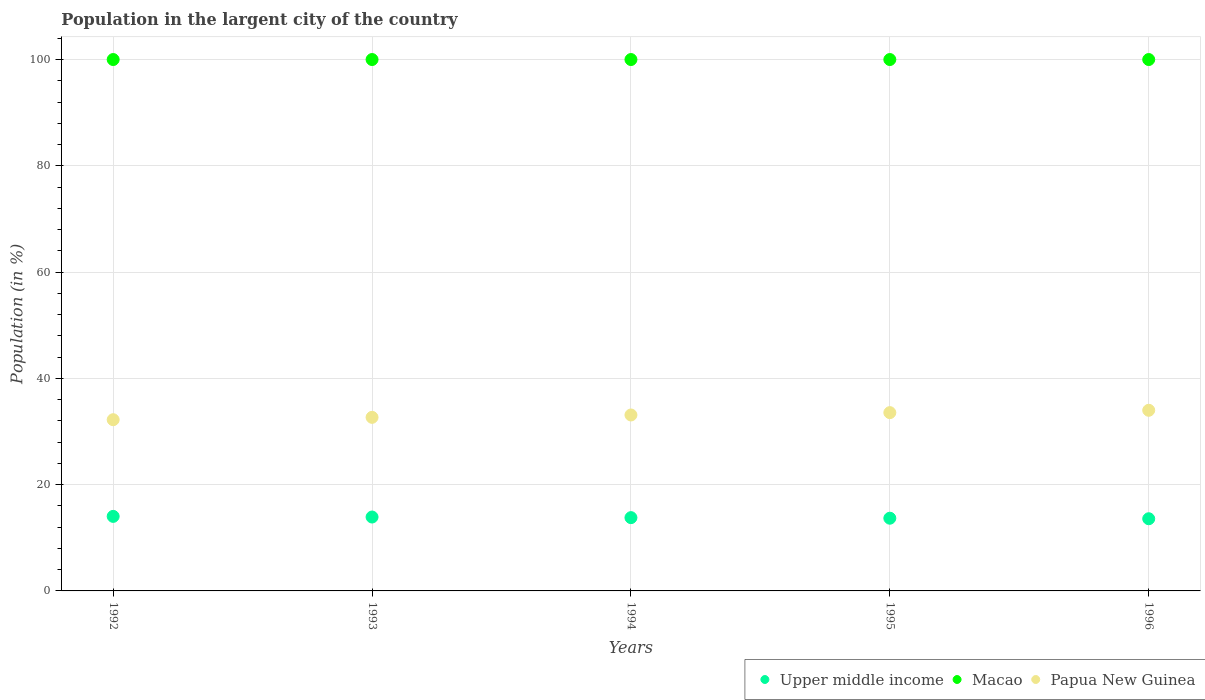How many different coloured dotlines are there?
Offer a terse response. 3. What is the percentage of population in the largent city in Upper middle income in 1993?
Give a very brief answer. 13.91. Across all years, what is the maximum percentage of population in the largent city in Papua New Guinea?
Provide a short and direct response. 33.99. Across all years, what is the minimum percentage of population in the largent city in Papua New Guinea?
Offer a terse response. 32.22. What is the total percentage of population in the largent city in Macao in the graph?
Your answer should be very brief. 500. What is the difference between the percentage of population in the largent city in Papua New Guinea in 1994 and that in 1995?
Your answer should be compact. -0.44. What is the difference between the percentage of population in the largent city in Upper middle income in 1993 and the percentage of population in the largent city in Papua New Guinea in 1996?
Your answer should be compact. -20.09. What is the average percentage of population in the largent city in Upper middle income per year?
Ensure brevity in your answer.  13.8. In the year 1994, what is the difference between the percentage of population in the largent city in Papua New Guinea and percentage of population in the largent city in Upper middle income?
Offer a very short reply. 19.32. In how many years, is the percentage of population in the largent city in Macao greater than 64 %?
Offer a terse response. 5. What is the ratio of the percentage of population in the largent city in Upper middle income in 1993 to that in 1996?
Offer a very short reply. 1.02. What is the difference between the highest and the second highest percentage of population in the largent city in Upper middle income?
Ensure brevity in your answer.  0.12. What is the difference between the highest and the lowest percentage of population in the largent city in Papua New Guinea?
Your answer should be very brief. 1.77. Is it the case that in every year, the sum of the percentage of population in the largent city in Upper middle income and percentage of population in the largent city in Macao  is greater than the percentage of population in the largent city in Papua New Guinea?
Your answer should be compact. Yes. Does the percentage of population in the largent city in Papua New Guinea monotonically increase over the years?
Make the answer very short. Yes. Is the percentage of population in the largent city in Macao strictly greater than the percentage of population in the largent city in Upper middle income over the years?
Keep it short and to the point. Yes. How many dotlines are there?
Provide a short and direct response. 3. How many years are there in the graph?
Your answer should be very brief. 5. Are the values on the major ticks of Y-axis written in scientific E-notation?
Offer a very short reply. No. How many legend labels are there?
Provide a short and direct response. 3. What is the title of the graph?
Your response must be concise. Population in the largent city of the country. Does "Bermuda" appear as one of the legend labels in the graph?
Give a very brief answer. No. What is the label or title of the Y-axis?
Provide a short and direct response. Population (in %). What is the Population (in %) in Upper middle income in 1992?
Your answer should be very brief. 14.03. What is the Population (in %) in Macao in 1992?
Make the answer very short. 100. What is the Population (in %) of Papua New Guinea in 1992?
Provide a succinct answer. 32.22. What is the Population (in %) of Upper middle income in 1993?
Provide a succinct answer. 13.91. What is the Population (in %) in Papua New Guinea in 1993?
Give a very brief answer. 32.66. What is the Population (in %) of Upper middle income in 1994?
Keep it short and to the point. 13.79. What is the Population (in %) of Macao in 1994?
Your response must be concise. 100. What is the Population (in %) of Papua New Guinea in 1994?
Give a very brief answer. 33.11. What is the Population (in %) in Upper middle income in 1995?
Offer a very short reply. 13.68. What is the Population (in %) of Papua New Guinea in 1995?
Provide a short and direct response. 33.55. What is the Population (in %) in Upper middle income in 1996?
Your response must be concise. 13.58. What is the Population (in %) of Macao in 1996?
Give a very brief answer. 100. What is the Population (in %) of Papua New Guinea in 1996?
Your answer should be compact. 33.99. Across all years, what is the maximum Population (in %) in Upper middle income?
Make the answer very short. 14.03. Across all years, what is the maximum Population (in %) in Papua New Guinea?
Make the answer very short. 33.99. Across all years, what is the minimum Population (in %) in Upper middle income?
Provide a short and direct response. 13.58. Across all years, what is the minimum Population (in %) in Macao?
Make the answer very short. 100. Across all years, what is the minimum Population (in %) of Papua New Guinea?
Your answer should be compact. 32.22. What is the total Population (in %) of Upper middle income in the graph?
Provide a succinct answer. 68.99. What is the total Population (in %) in Macao in the graph?
Give a very brief answer. 500. What is the total Population (in %) of Papua New Guinea in the graph?
Give a very brief answer. 165.54. What is the difference between the Population (in %) of Upper middle income in 1992 and that in 1993?
Your answer should be compact. 0.12. What is the difference between the Population (in %) of Papua New Guinea in 1992 and that in 1993?
Offer a terse response. -0.44. What is the difference between the Population (in %) of Upper middle income in 1992 and that in 1994?
Offer a very short reply. 0.24. What is the difference between the Population (in %) of Papua New Guinea in 1992 and that in 1994?
Give a very brief answer. -0.89. What is the difference between the Population (in %) in Upper middle income in 1992 and that in 1995?
Offer a terse response. 0.34. What is the difference between the Population (in %) in Papua New Guinea in 1992 and that in 1995?
Give a very brief answer. -1.33. What is the difference between the Population (in %) of Upper middle income in 1992 and that in 1996?
Offer a very short reply. 0.45. What is the difference between the Population (in %) in Macao in 1992 and that in 1996?
Give a very brief answer. 0. What is the difference between the Population (in %) in Papua New Guinea in 1992 and that in 1996?
Give a very brief answer. -1.77. What is the difference between the Population (in %) in Upper middle income in 1993 and that in 1994?
Offer a very short reply. 0.12. What is the difference between the Population (in %) in Papua New Guinea in 1993 and that in 1994?
Give a very brief answer. -0.44. What is the difference between the Population (in %) of Upper middle income in 1993 and that in 1995?
Your response must be concise. 0.22. What is the difference between the Population (in %) of Macao in 1993 and that in 1995?
Keep it short and to the point. 0. What is the difference between the Population (in %) of Papua New Guinea in 1993 and that in 1995?
Offer a terse response. -0.89. What is the difference between the Population (in %) in Upper middle income in 1993 and that in 1996?
Provide a short and direct response. 0.32. What is the difference between the Population (in %) of Papua New Guinea in 1993 and that in 1996?
Provide a short and direct response. -1.33. What is the difference between the Population (in %) of Upper middle income in 1994 and that in 1995?
Ensure brevity in your answer.  0.11. What is the difference between the Population (in %) in Macao in 1994 and that in 1995?
Your response must be concise. -0. What is the difference between the Population (in %) in Papua New Guinea in 1994 and that in 1995?
Ensure brevity in your answer.  -0.44. What is the difference between the Population (in %) of Upper middle income in 1994 and that in 1996?
Ensure brevity in your answer.  0.21. What is the difference between the Population (in %) in Papua New Guinea in 1994 and that in 1996?
Your response must be concise. -0.88. What is the difference between the Population (in %) in Upper middle income in 1995 and that in 1996?
Offer a terse response. 0.1. What is the difference between the Population (in %) of Macao in 1995 and that in 1996?
Provide a succinct answer. 0. What is the difference between the Population (in %) of Papua New Guinea in 1995 and that in 1996?
Make the answer very short. -0.44. What is the difference between the Population (in %) in Upper middle income in 1992 and the Population (in %) in Macao in 1993?
Provide a succinct answer. -85.97. What is the difference between the Population (in %) of Upper middle income in 1992 and the Population (in %) of Papua New Guinea in 1993?
Keep it short and to the point. -18.64. What is the difference between the Population (in %) in Macao in 1992 and the Population (in %) in Papua New Guinea in 1993?
Offer a very short reply. 67.34. What is the difference between the Population (in %) of Upper middle income in 1992 and the Population (in %) of Macao in 1994?
Provide a succinct answer. -85.97. What is the difference between the Population (in %) in Upper middle income in 1992 and the Population (in %) in Papua New Guinea in 1994?
Ensure brevity in your answer.  -19.08. What is the difference between the Population (in %) in Macao in 1992 and the Population (in %) in Papua New Guinea in 1994?
Offer a terse response. 66.89. What is the difference between the Population (in %) of Upper middle income in 1992 and the Population (in %) of Macao in 1995?
Make the answer very short. -85.97. What is the difference between the Population (in %) in Upper middle income in 1992 and the Population (in %) in Papua New Guinea in 1995?
Provide a succinct answer. -19.52. What is the difference between the Population (in %) in Macao in 1992 and the Population (in %) in Papua New Guinea in 1995?
Offer a terse response. 66.45. What is the difference between the Population (in %) in Upper middle income in 1992 and the Population (in %) in Macao in 1996?
Make the answer very short. -85.97. What is the difference between the Population (in %) of Upper middle income in 1992 and the Population (in %) of Papua New Guinea in 1996?
Offer a terse response. -19.97. What is the difference between the Population (in %) in Macao in 1992 and the Population (in %) in Papua New Guinea in 1996?
Make the answer very short. 66.01. What is the difference between the Population (in %) of Upper middle income in 1993 and the Population (in %) of Macao in 1994?
Your answer should be very brief. -86.09. What is the difference between the Population (in %) of Upper middle income in 1993 and the Population (in %) of Papua New Guinea in 1994?
Ensure brevity in your answer.  -19.2. What is the difference between the Population (in %) in Macao in 1993 and the Population (in %) in Papua New Guinea in 1994?
Offer a terse response. 66.89. What is the difference between the Population (in %) of Upper middle income in 1993 and the Population (in %) of Macao in 1995?
Provide a short and direct response. -86.09. What is the difference between the Population (in %) of Upper middle income in 1993 and the Population (in %) of Papua New Guinea in 1995?
Give a very brief answer. -19.65. What is the difference between the Population (in %) of Macao in 1993 and the Population (in %) of Papua New Guinea in 1995?
Your answer should be very brief. 66.45. What is the difference between the Population (in %) in Upper middle income in 1993 and the Population (in %) in Macao in 1996?
Give a very brief answer. -86.09. What is the difference between the Population (in %) in Upper middle income in 1993 and the Population (in %) in Papua New Guinea in 1996?
Ensure brevity in your answer.  -20.09. What is the difference between the Population (in %) in Macao in 1993 and the Population (in %) in Papua New Guinea in 1996?
Ensure brevity in your answer.  66.01. What is the difference between the Population (in %) of Upper middle income in 1994 and the Population (in %) of Macao in 1995?
Provide a succinct answer. -86.21. What is the difference between the Population (in %) of Upper middle income in 1994 and the Population (in %) of Papua New Guinea in 1995?
Your answer should be very brief. -19.76. What is the difference between the Population (in %) in Macao in 1994 and the Population (in %) in Papua New Guinea in 1995?
Provide a succinct answer. 66.45. What is the difference between the Population (in %) in Upper middle income in 1994 and the Population (in %) in Macao in 1996?
Keep it short and to the point. -86.21. What is the difference between the Population (in %) of Upper middle income in 1994 and the Population (in %) of Papua New Guinea in 1996?
Provide a succinct answer. -20.2. What is the difference between the Population (in %) of Macao in 1994 and the Population (in %) of Papua New Guinea in 1996?
Offer a terse response. 66.01. What is the difference between the Population (in %) of Upper middle income in 1995 and the Population (in %) of Macao in 1996?
Keep it short and to the point. -86.32. What is the difference between the Population (in %) in Upper middle income in 1995 and the Population (in %) in Papua New Guinea in 1996?
Provide a succinct answer. -20.31. What is the difference between the Population (in %) in Macao in 1995 and the Population (in %) in Papua New Guinea in 1996?
Offer a terse response. 66.01. What is the average Population (in %) in Upper middle income per year?
Make the answer very short. 13.8. What is the average Population (in %) in Macao per year?
Offer a terse response. 100. What is the average Population (in %) of Papua New Guinea per year?
Your answer should be compact. 33.11. In the year 1992, what is the difference between the Population (in %) in Upper middle income and Population (in %) in Macao?
Provide a short and direct response. -85.97. In the year 1992, what is the difference between the Population (in %) of Upper middle income and Population (in %) of Papua New Guinea?
Offer a very short reply. -18.19. In the year 1992, what is the difference between the Population (in %) of Macao and Population (in %) of Papua New Guinea?
Your answer should be very brief. 67.78. In the year 1993, what is the difference between the Population (in %) in Upper middle income and Population (in %) in Macao?
Ensure brevity in your answer.  -86.09. In the year 1993, what is the difference between the Population (in %) in Upper middle income and Population (in %) in Papua New Guinea?
Make the answer very short. -18.76. In the year 1993, what is the difference between the Population (in %) of Macao and Population (in %) of Papua New Guinea?
Provide a succinct answer. 67.34. In the year 1994, what is the difference between the Population (in %) in Upper middle income and Population (in %) in Macao?
Offer a very short reply. -86.21. In the year 1994, what is the difference between the Population (in %) of Upper middle income and Population (in %) of Papua New Guinea?
Make the answer very short. -19.32. In the year 1994, what is the difference between the Population (in %) of Macao and Population (in %) of Papua New Guinea?
Your answer should be very brief. 66.89. In the year 1995, what is the difference between the Population (in %) in Upper middle income and Population (in %) in Macao?
Your answer should be compact. -86.32. In the year 1995, what is the difference between the Population (in %) of Upper middle income and Population (in %) of Papua New Guinea?
Provide a short and direct response. -19.87. In the year 1995, what is the difference between the Population (in %) in Macao and Population (in %) in Papua New Guinea?
Keep it short and to the point. 66.45. In the year 1996, what is the difference between the Population (in %) of Upper middle income and Population (in %) of Macao?
Your response must be concise. -86.42. In the year 1996, what is the difference between the Population (in %) in Upper middle income and Population (in %) in Papua New Guinea?
Offer a very short reply. -20.41. In the year 1996, what is the difference between the Population (in %) of Macao and Population (in %) of Papua New Guinea?
Make the answer very short. 66.01. What is the ratio of the Population (in %) of Upper middle income in 1992 to that in 1993?
Offer a terse response. 1.01. What is the ratio of the Population (in %) of Papua New Guinea in 1992 to that in 1993?
Offer a terse response. 0.99. What is the ratio of the Population (in %) of Upper middle income in 1992 to that in 1994?
Make the answer very short. 1.02. What is the ratio of the Population (in %) in Papua New Guinea in 1992 to that in 1994?
Ensure brevity in your answer.  0.97. What is the ratio of the Population (in %) in Upper middle income in 1992 to that in 1995?
Your response must be concise. 1.03. What is the ratio of the Population (in %) of Papua New Guinea in 1992 to that in 1995?
Your answer should be very brief. 0.96. What is the ratio of the Population (in %) of Upper middle income in 1992 to that in 1996?
Offer a very short reply. 1.03. What is the ratio of the Population (in %) of Macao in 1992 to that in 1996?
Provide a short and direct response. 1. What is the ratio of the Population (in %) of Papua New Guinea in 1992 to that in 1996?
Your response must be concise. 0.95. What is the ratio of the Population (in %) of Upper middle income in 1993 to that in 1994?
Your response must be concise. 1.01. What is the ratio of the Population (in %) in Papua New Guinea in 1993 to that in 1994?
Offer a very short reply. 0.99. What is the ratio of the Population (in %) in Upper middle income in 1993 to that in 1995?
Your answer should be compact. 1.02. What is the ratio of the Population (in %) of Macao in 1993 to that in 1995?
Make the answer very short. 1. What is the ratio of the Population (in %) of Papua New Guinea in 1993 to that in 1995?
Give a very brief answer. 0.97. What is the ratio of the Population (in %) of Upper middle income in 1993 to that in 1996?
Your response must be concise. 1.02. What is the ratio of the Population (in %) in Macao in 1993 to that in 1996?
Your answer should be compact. 1. What is the ratio of the Population (in %) in Papua New Guinea in 1993 to that in 1996?
Your answer should be very brief. 0.96. What is the ratio of the Population (in %) in Upper middle income in 1994 to that in 1995?
Your response must be concise. 1.01. What is the ratio of the Population (in %) of Papua New Guinea in 1994 to that in 1995?
Give a very brief answer. 0.99. What is the ratio of the Population (in %) in Upper middle income in 1994 to that in 1996?
Ensure brevity in your answer.  1.02. What is the ratio of the Population (in %) of Macao in 1994 to that in 1996?
Your answer should be very brief. 1. What is the ratio of the Population (in %) in Upper middle income in 1995 to that in 1996?
Make the answer very short. 1.01. What is the difference between the highest and the second highest Population (in %) in Upper middle income?
Make the answer very short. 0.12. What is the difference between the highest and the second highest Population (in %) in Macao?
Your response must be concise. 0. What is the difference between the highest and the second highest Population (in %) in Papua New Guinea?
Provide a succinct answer. 0.44. What is the difference between the highest and the lowest Population (in %) in Upper middle income?
Provide a short and direct response. 0.45. What is the difference between the highest and the lowest Population (in %) in Macao?
Make the answer very short. 0. What is the difference between the highest and the lowest Population (in %) in Papua New Guinea?
Your response must be concise. 1.77. 